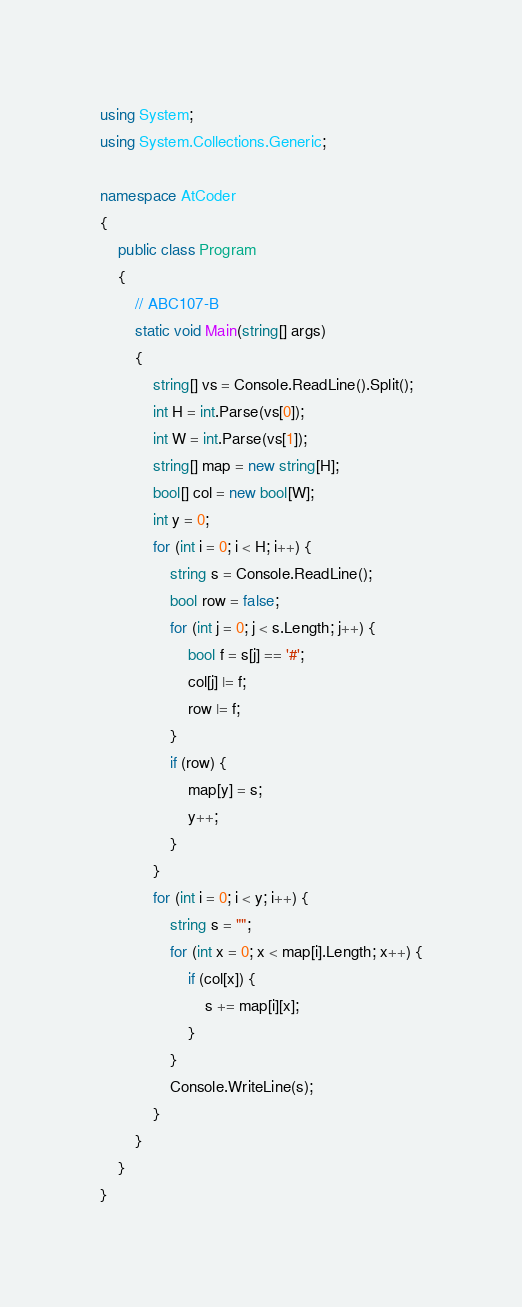<code> <loc_0><loc_0><loc_500><loc_500><_C#_>using System;
using System.Collections.Generic;

namespace AtCoder
{
	public class Program
	{
		// ABC107-B
		static void Main(string[] args)
		{
			string[] vs = Console.ReadLine().Split();
			int H = int.Parse(vs[0]);
			int W = int.Parse(vs[1]);
			string[] map = new string[H];
			bool[] col = new bool[W];
			int y = 0;
			for (int i = 0; i < H; i++) {
				string s = Console.ReadLine();
				bool row = false;
				for (int j = 0; j < s.Length; j++) {
					bool f = s[j] == '#';
					col[j] |= f;
					row |= f;
				}
				if (row) {
					map[y] = s;
					y++;
				}
			}
			for (int i = 0; i < y; i++) {
				string s = "";
				for (int x = 0; x < map[i].Length; x++) {
					if (col[x]) {
						s += map[i][x];
					}
				}
				Console.WriteLine(s);
			}
		}
	}
}
</code> 